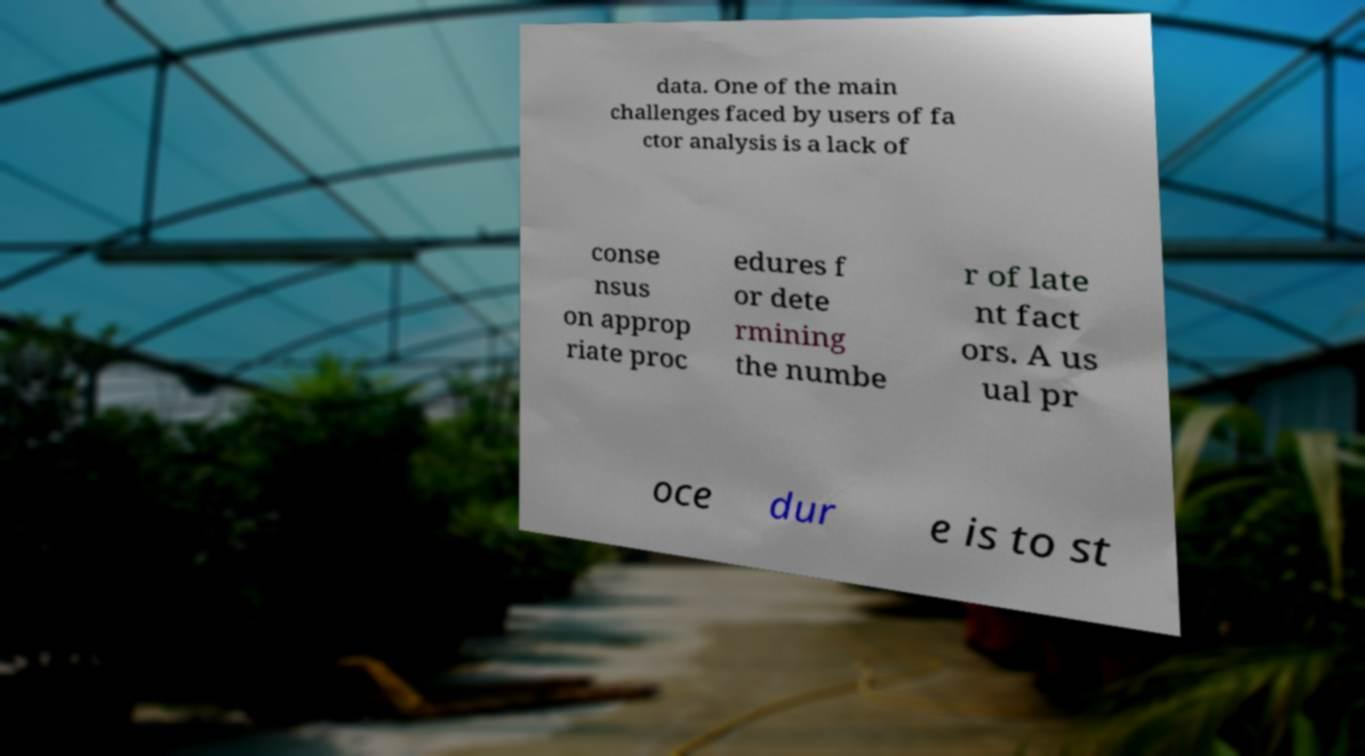Can you accurately transcribe the text from the provided image for me? data. One of the main challenges faced by users of fa ctor analysis is a lack of conse nsus on approp riate proc edures f or dete rmining the numbe r of late nt fact ors. A us ual pr oce dur e is to st 